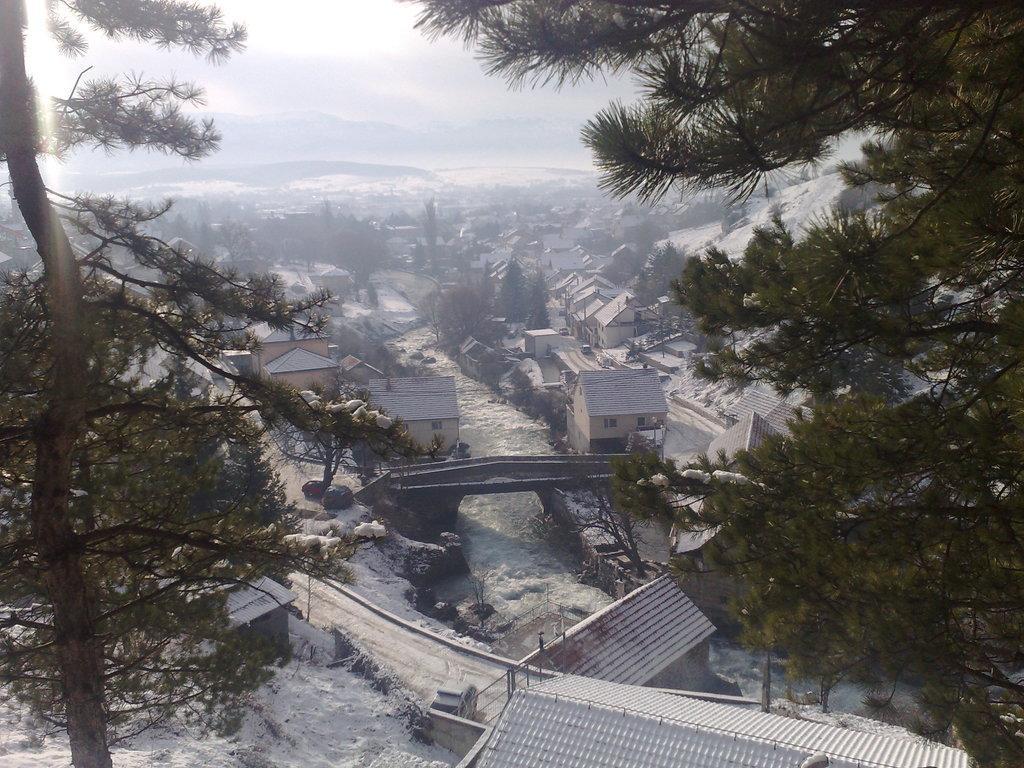Could you give a brief overview of what you see in this image? In this picture we can see many buildings. At the bottom there is a road, beside that we can see the river. In the center there is it a bridge. In the background we can see mountain and snow. On the right there is a tree. At the top we can see sky and clouds. 